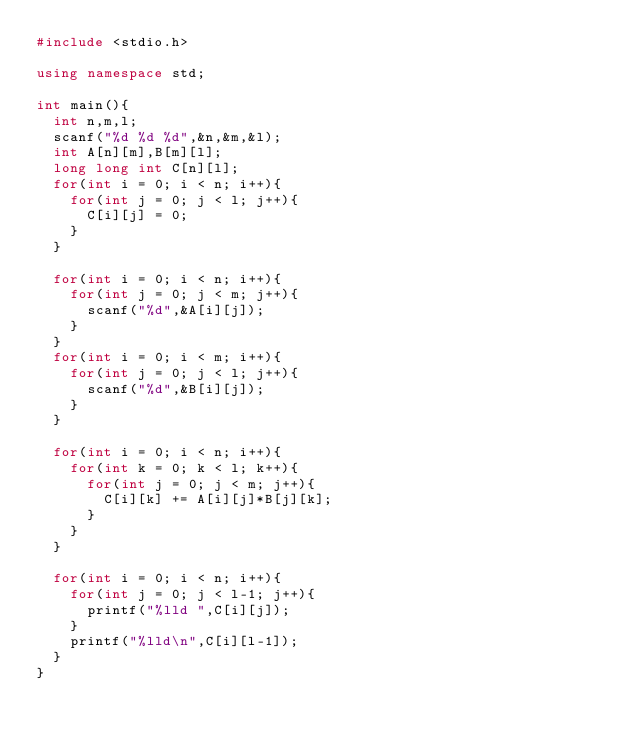<code> <loc_0><loc_0><loc_500><loc_500><_C++_>#include <stdio.h>

using namespace std;

int main(){
	int n,m,l;
	scanf("%d %d %d",&n,&m,&l);
	int A[n][m],B[m][l];
	long long int C[n][l];
	for(int i = 0; i < n; i++){
		for(int j = 0; j < l; j++){
			C[i][j] = 0;
		}
	}

	for(int i = 0; i < n; i++){
		for(int j = 0; j < m; j++){
			scanf("%d",&A[i][j]);
		}
	}
	for(int i = 0; i < m; i++){
		for(int j = 0; j < l; j++){
			scanf("%d",&B[i][j]);
		}
	}

	for(int i = 0; i < n; i++){
		for(int k = 0; k < l; k++){
			for(int j = 0; j < m; j++){
				C[i][k] += A[i][j]*B[j][k];
			}
		}
	}

	for(int i = 0; i < n; i++){
		for(int j = 0; j < l-1; j++){
			printf("%lld ",C[i][j]);
		}
		printf("%lld\n",C[i][l-1]);
	}
}

</code> 